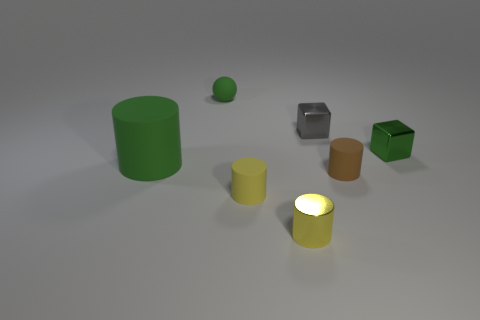Can you describe the lighting in the scene? The lighting in the scene is subdued with soft shadows, indicating a diffused light source from above. The yellow cylinder emits a glow, suggesting it's self-illuminating, which adds a warm light to its immediate surroundings. 